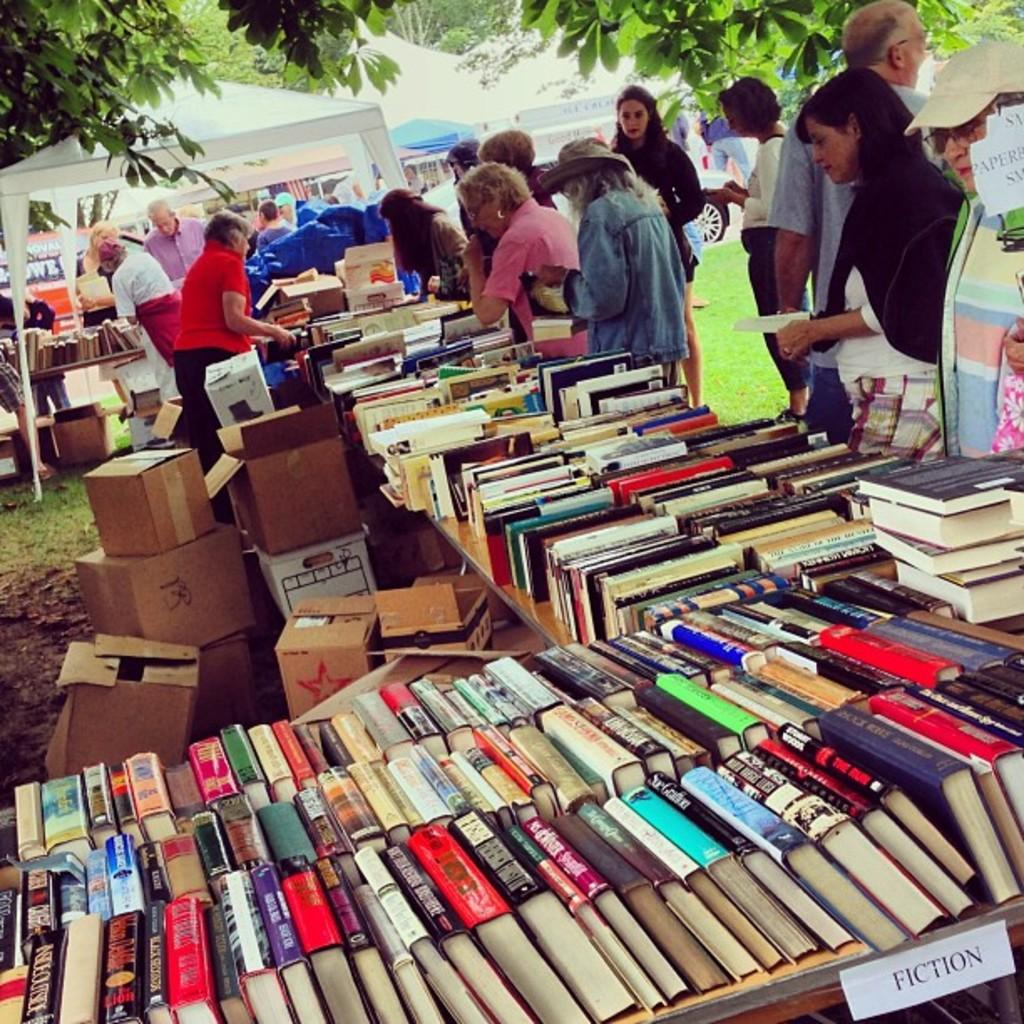<image>
Give a short and clear explanation of the subsequent image. Several book spines are viewable on a table at a sale with the description of FICTION. 